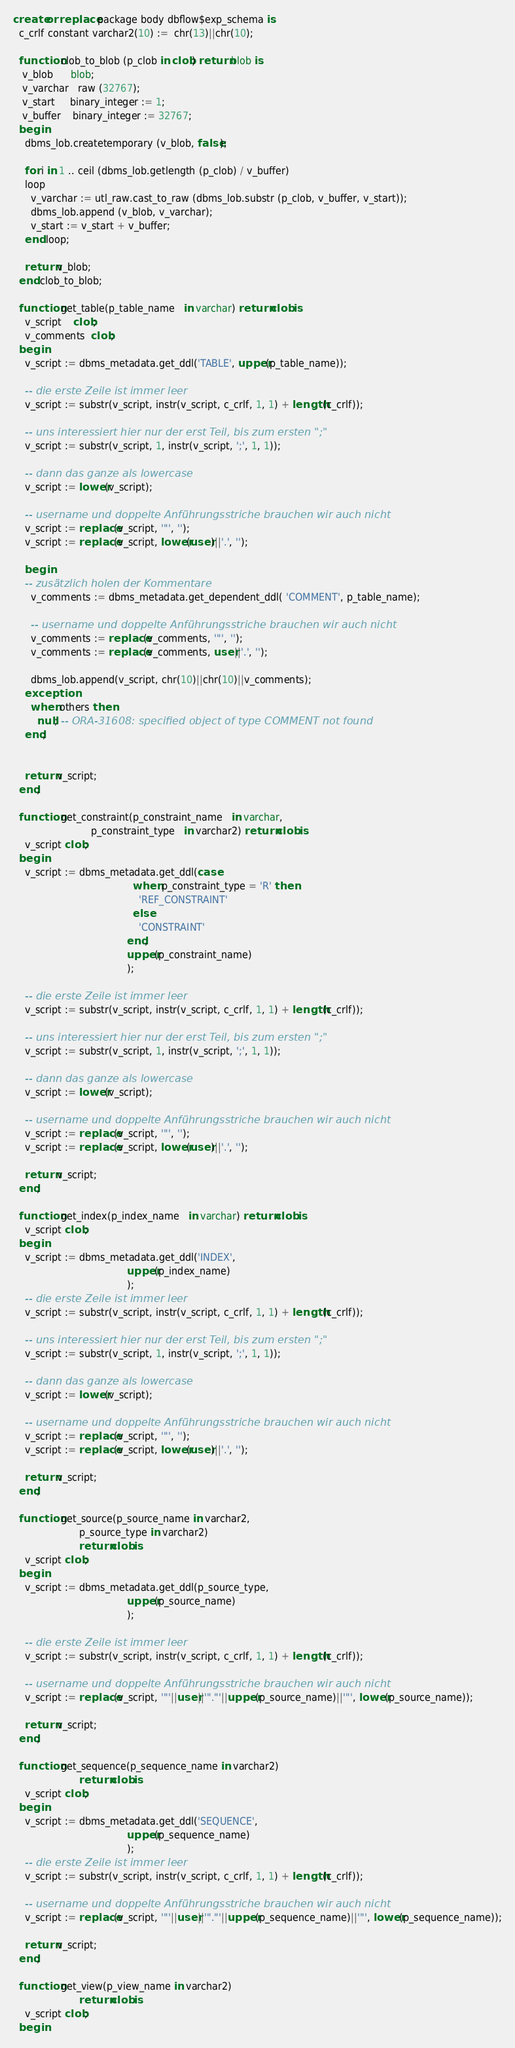<code> <loc_0><loc_0><loc_500><loc_500><_SQL_>create or replace package body dbflow$exp_schema is
  c_crlf constant varchar2(10) :=  chr(13)||chr(10);

  function clob_to_blob (p_clob in clob) return blob is
   v_blob      blob;
   v_varchar   raw (32767);
   v_start     binary_integer := 1;
   v_buffer    binary_integer := 32767;
  begin
    dbms_lob.createtemporary (v_blob, false);

    for i in 1 .. ceil (dbms_lob.getlength (p_clob) / v_buffer)
    loop
      v_varchar := utl_raw.cast_to_raw (dbms_lob.substr (p_clob, v_buffer, v_start));
      dbms_lob.append (v_blob, v_varchar);
      v_start := v_start + v_buffer;
    end loop;

    return v_blob;
  end clob_to_blob;

  function get_table(p_table_name   in varchar) return clob is
    v_script    clob;
    v_comments  clob;
  begin
    v_script := dbms_metadata.get_ddl('TABLE', upper(p_table_name));

    -- die erste Zeile ist immer leer
    v_script := substr(v_script, instr(v_script, c_crlf, 1, 1) + length(c_crlf));

    -- uns interessiert hier nur der erst Teil, bis zum ersten ";"
    v_script := substr(v_script, 1, instr(v_script, ';', 1, 1));

    -- dann das ganze als lowercase
    v_script := lower(v_script);

    -- username und doppelte Anführungsstriche brauchen wir auch nicht
    v_script := replace(v_script, '"', '');
    v_script := replace(v_script, lower(user)||'.', '');

    begin
    -- zusätzlich holen der Kommentare
      v_comments := dbms_metadata.get_dependent_ddl( 'COMMENT', p_table_name);

      -- username und doppelte Anführungsstriche brauchen wir auch nicht
      v_comments := replace(v_comments, '"', '');
      v_comments := replace(v_comments, user||'.', '');

      dbms_lob.append(v_script, chr(10)||chr(10)||v_comments);
    exception
      when others then
        null; -- ORA-31608: specified object of type COMMENT not found
    end;


    return v_script;
  end;

  function get_constraint(p_constraint_name   in varchar,
                          p_constraint_type   in varchar2) return clob is
    v_script clob;
  begin
    v_script := dbms_metadata.get_ddl(case
                                        when p_constraint_type = 'R' then
                                          'REF_CONSTRAINT'
                                        else
                                          'CONSTRAINT'
                                      end,
                                      upper(p_constraint_name)
                                      );

    -- die erste Zeile ist immer leer
    v_script := substr(v_script, instr(v_script, c_crlf, 1, 1) + length(c_crlf));

    -- uns interessiert hier nur der erst Teil, bis zum ersten ";"
    v_script := substr(v_script, 1, instr(v_script, ';', 1, 1));

    -- dann das ganze als lowercase
    v_script := lower(v_script);

    -- username und doppelte Anführungsstriche brauchen wir auch nicht
    v_script := replace(v_script, '"', '');
    v_script := replace(v_script, lower(user)||'.', '');

    return v_script;
  end;

  function get_index(p_index_name   in varchar) return clob is
    v_script clob;
  begin
    v_script := dbms_metadata.get_ddl('INDEX',
                                      upper(p_index_name)
                                      );
    -- die erste Zeile ist immer leer
    v_script := substr(v_script, instr(v_script, c_crlf, 1, 1) + length(c_crlf));

    -- uns interessiert hier nur der erst Teil, bis zum ersten ";"
    v_script := substr(v_script, 1, instr(v_script, ';', 1, 1));

    -- dann das ganze als lowercase
    v_script := lower(v_script);

    -- username und doppelte Anführungsstriche brauchen wir auch nicht
    v_script := replace(v_script, '"', '');
    v_script := replace(v_script, lower(user)||'.', '');

    return v_script;
  end;

  function get_source(p_source_name in varchar2,
                      p_source_type in varchar2)
                      return clob is
    v_script clob;
  begin
    v_script := dbms_metadata.get_ddl(p_source_type,
                                      upper(p_source_name)
                                      );

    -- die erste Zeile ist immer leer
    v_script := substr(v_script, instr(v_script, c_crlf, 1, 1) + length(c_crlf));

    -- username und doppelte Anführungsstriche brauchen wir auch nicht
    v_script := replace(v_script, '"'||user||'"."'||upper(p_source_name)||'"', lower(p_source_name));

    return v_script;
  end;

  function get_sequence(p_sequence_name in varchar2)
                      return clob is
    v_script clob;
  begin
    v_script := dbms_metadata.get_ddl('SEQUENCE',
                                      upper(p_sequence_name)
                                      );
    -- die erste Zeile ist immer leer
    v_script := substr(v_script, instr(v_script, c_crlf, 1, 1) + length(c_crlf));

    -- username und doppelte Anführungsstriche brauchen wir auch nicht
    v_script := replace(v_script, '"'||user||'"."'||upper(p_sequence_name)||'"', lower(p_sequence_name));

    return v_script;
  end;

  function get_view(p_view_name in varchar2)
                      return clob is
    v_script clob;
  begin</code> 